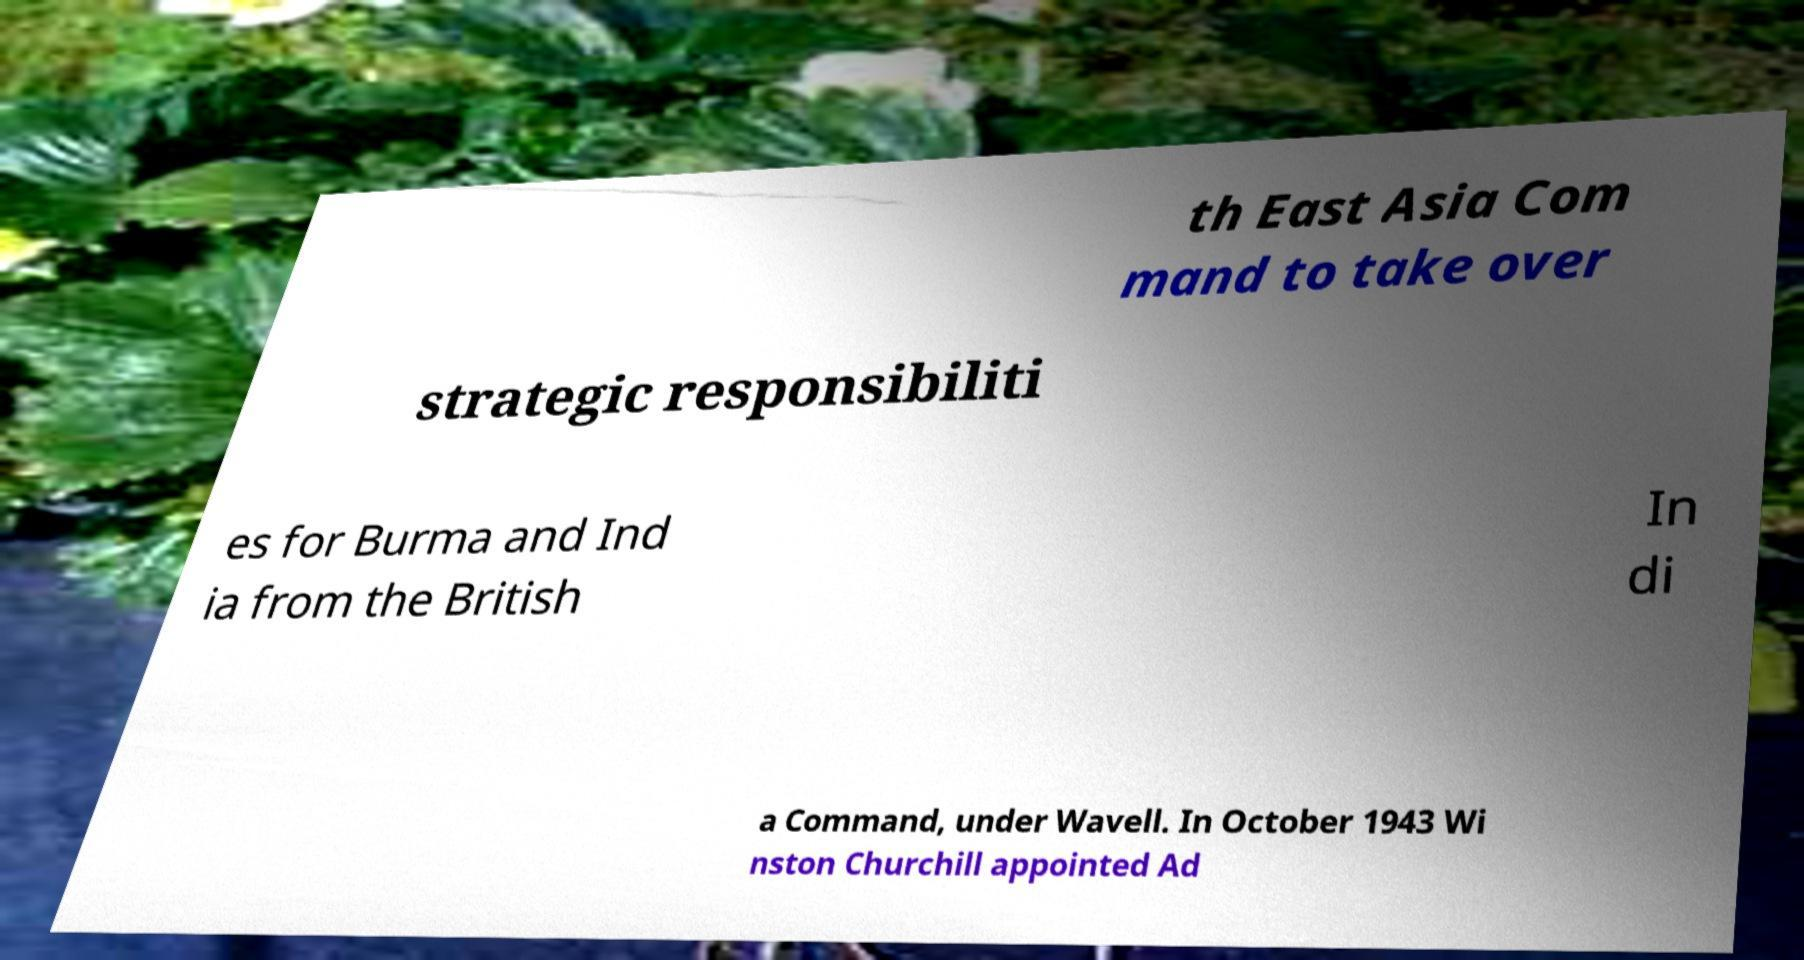Can you read and provide the text displayed in the image?This photo seems to have some interesting text. Can you extract and type it out for me? th East Asia Com mand to take over strategic responsibiliti es for Burma and Ind ia from the British In di a Command, under Wavell. In October 1943 Wi nston Churchill appointed Ad 